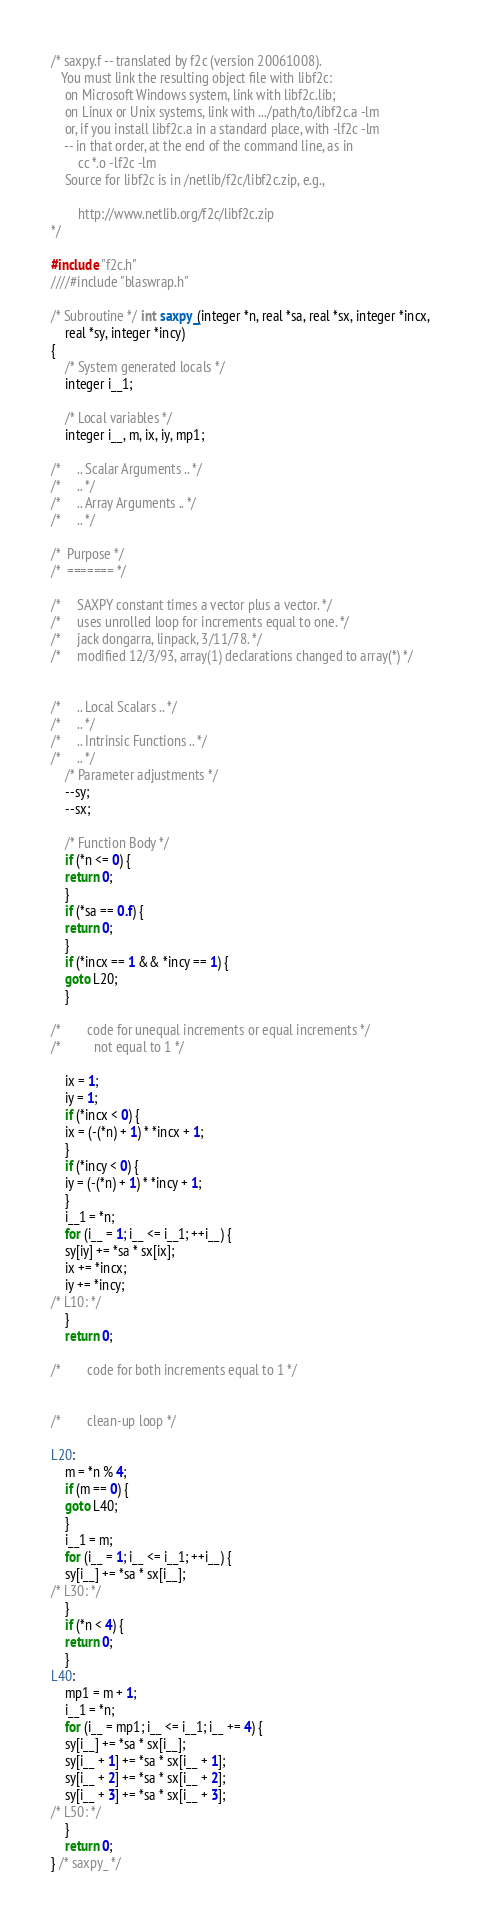Convert code to text. <code><loc_0><loc_0><loc_500><loc_500><_C_>/* saxpy.f -- translated by f2c (version 20061008).
   You must link the resulting object file with libf2c:
	on Microsoft Windows system, link with libf2c.lib;
	on Linux or Unix systems, link with .../path/to/libf2c.a -lm
	or, if you install libf2c.a in a standard place, with -lf2c -lm
	-- in that order, at the end of the command line, as in
		cc *.o -lf2c -lm
	Source for libf2c is in /netlib/f2c/libf2c.zip, e.g.,

		http://www.netlib.org/f2c/libf2c.zip
*/

#include "f2c.h"
////#include "blaswrap.h"

/* Subroutine */ int saxpy_(integer *n, real *sa, real *sx, integer *incx, 
	real *sy, integer *incy)
{
    /* System generated locals */
    integer i__1;

    /* Local variables */
    integer i__, m, ix, iy, mp1;

/*     .. Scalar Arguments .. */
/*     .. */
/*     .. Array Arguments .. */
/*     .. */

/*  Purpose */
/*  ======= */

/*     SAXPY constant times a vector plus a vector. */
/*     uses unrolled loop for increments equal to one. */
/*     jack dongarra, linpack, 3/11/78. */
/*     modified 12/3/93, array(1) declarations changed to array(*) */


/*     .. Local Scalars .. */
/*     .. */
/*     .. Intrinsic Functions .. */
/*     .. */
    /* Parameter adjustments */
    --sy;
    --sx;

    /* Function Body */
    if (*n <= 0) {
	return 0;
    }
    if (*sa == 0.f) {
	return 0;
    }
    if (*incx == 1 && *incy == 1) {
	goto L20;
    }

/*        code for unequal increments or equal increments */
/*          not equal to 1 */

    ix = 1;
    iy = 1;
    if (*incx < 0) {
	ix = (-(*n) + 1) * *incx + 1;
    }
    if (*incy < 0) {
	iy = (-(*n) + 1) * *incy + 1;
    }
    i__1 = *n;
    for (i__ = 1; i__ <= i__1; ++i__) {
	sy[iy] += *sa * sx[ix];
	ix += *incx;
	iy += *incy;
/* L10: */
    }
    return 0;

/*        code for both increments equal to 1 */


/*        clean-up loop */

L20:
    m = *n % 4;
    if (m == 0) {
	goto L40;
    }
    i__1 = m;
    for (i__ = 1; i__ <= i__1; ++i__) {
	sy[i__] += *sa * sx[i__];
/* L30: */
    }
    if (*n < 4) {
	return 0;
    }
L40:
    mp1 = m + 1;
    i__1 = *n;
    for (i__ = mp1; i__ <= i__1; i__ += 4) {
	sy[i__] += *sa * sx[i__];
	sy[i__ + 1] += *sa * sx[i__ + 1];
	sy[i__ + 2] += *sa * sx[i__ + 2];
	sy[i__ + 3] += *sa * sx[i__ + 3];
/* L50: */
    }
    return 0;
} /* saxpy_ */
</code> 